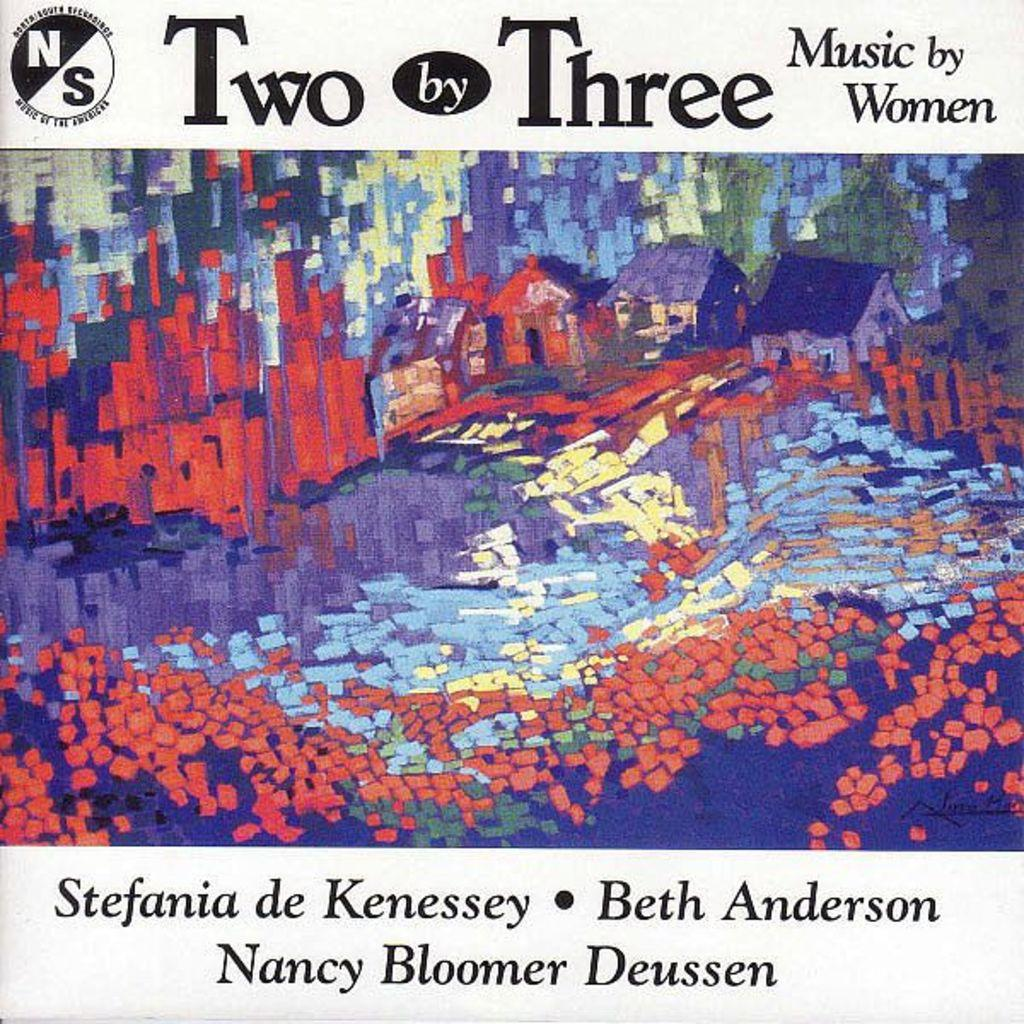Provide a one-sentence caption for the provided image. The cover of Two by Three an album of music by Women. 